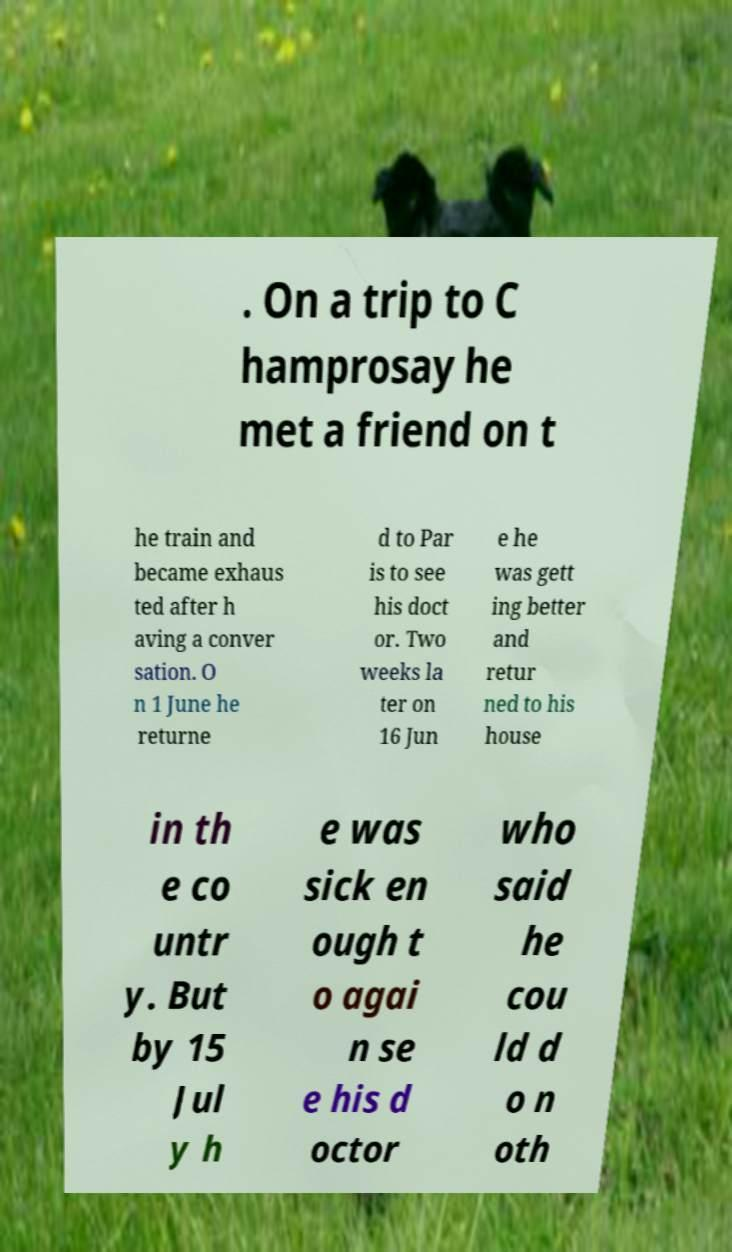What messages or text are displayed in this image? I need them in a readable, typed format. . On a trip to C hamprosay he met a friend on t he train and became exhaus ted after h aving a conver sation. O n 1 June he returne d to Par is to see his doct or. Two weeks la ter on 16 Jun e he was gett ing better and retur ned to his house in th e co untr y. But by 15 Jul y h e was sick en ough t o agai n se e his d octor who said he cou ld d o n oth 